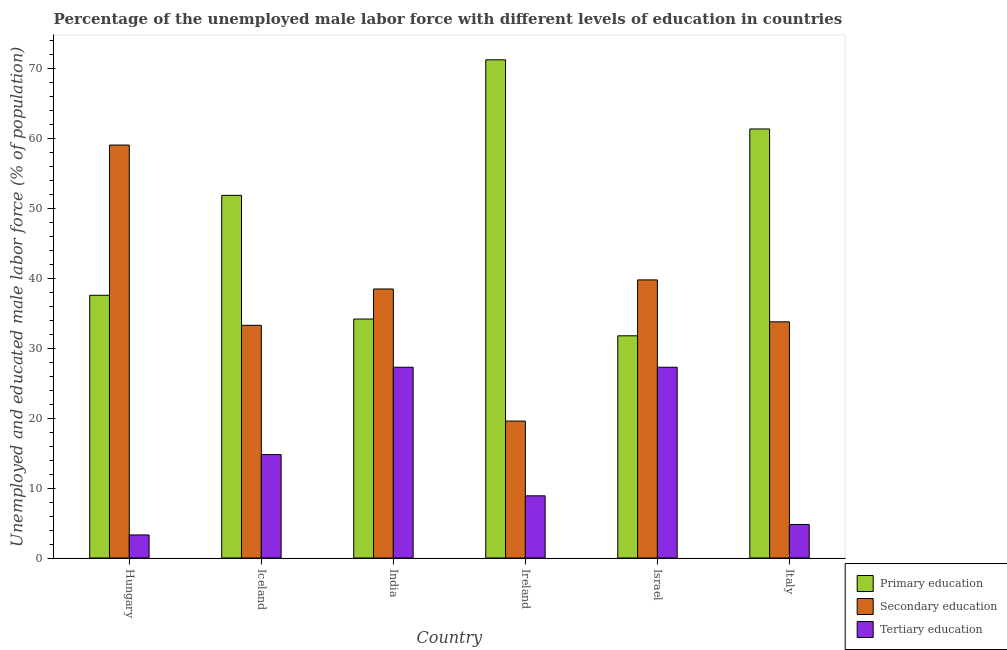How many different coloured bars are there?
Your answer should be very brief. 3. How many bars are there on the 1st tick from the left?
Keep it short and to the point. 3. How many bars are there on the 1st tick from the right?
Ensure brevity in your answer.  3. What is the label of the 4th group of bars from the left?
Ensure brevity in your answer.  Ireland. In how many cases, is the number of bars for a given country not equal to the number of legend labels?
Keep it short and to the point. 0. What is the percentage of male labor force who received primary education in Hungary?
Your answer should be very brief. 37.6. Across all countries, what is the maximum percentage of male labor force who received secondary education?
Provide a short and direct response. 59.1. Across all countries, what is the minimum percentage of male labor force who received secondary education?
Ensure brevity in your answer.  19.6. What is the total percentage of male labor force who received primary education in the graph?
Your answer should be compact. 288.2. What is the difference between the percentage of male labor force who received tertiary education in Hungary and that in Israel?
Provide a short and direct response. -24. What is the difference between the percentage of male labor force who received tertiary education in Iceland and the percentage of male labor force who received secondary education in Ireland?
Provide a short and direct response. -4.8. What is the average percentage of male labor force who received secondary education per country?
Offer a very short reply. 37.35. What is the difference between the percentage of male labor force who received tertiary education and percentage of male labor force who received secondary education in Ireland?
Make the answer very short. -10.7. In how many countries, is the percentage of male labor force who received tertiary education greater than 4 %?
Keep it short and to the point. 5. What is the ratio of the percentage of male labor force who received tertiary education in Hungary to that in Iceland?
Provide a short and direct response. 0.22. Is the difference between the percentage of male labor force who received primary education in Hungary and Iceland greater than the difference between the percentage of male labor force who received tertiary education in Hungary and Iceland?
Give a very brief answer. No. What is the difference between the highest and the second highest percentage of male labor force who received primary education?
Offer a very short reply. 9.9. What is the difference between the highest and the lowest percentage of male labor force who received secondary education?
Give a very brief answer. 39.5. In how many countries, is the percentage of male labor force who received primary education greater than the average percentage of male labor force who received primary education taken over all countries?
Offer a terse response. 3. Is the sum of the percentage of male labor force who received secondary education in Israel and Italy greater than the maximum percentage of male labor force who received primary education across all countries?
Make the answer very short. Yes. What does the 1st bar from the left in Hungary represents?
Ensure brevity in your answer.  Primary education. What does the 1st bar from the right in Italy represents?
Your answer should be very brief. Tertiary education. How many bars are there?
Offer a terse response. 18. Are all the bars in the graph horizontal?
Offer a terse response. No. How many countries are there in the graph?
Your answer should be compact. 6. What is the title of the graph?
Make the answer very short. Percentage of the unemployed male labor force with different levels of education in countries. What is the label or title of the X-axis?
Ensure brevity in your answer.  Country. What is the label or title of the Y-axis?
Offer a very short reply. Unemployed and educated male labor force (% of population). What is the Unemployed and educated male labor force (% of population) of Primary education in Hungary?
Make the answer very short. 37.6. What is the Unemployed and educated male labor force (% of population) in Secondary education in Hungary?
Your answer should be compact. 59.1. What is the Unemployed and educated male labor force (% of population) in Tertiary education in Hungary?
Offer a terse response. 3.3. What is the Unemployed and educated male labor force (% of population) of Primary education in Iceland?
Your answer should be very brief. 51.9. What is the Unemployed and educated male labor force (% of population) of Secondary education in Iceland?
Provide a short and direct response. 33.3. What is the Unemployed and educated male labor force (% of population) of Tertiary education in Iceland?
Offer a very short reply. 14.8. What is the Unemployed and educated male labor force (% of population) of Primary education in India?
Provide a succinct answer. 34.2. What is the Unemployed and educated male labor force (% of population) in Secondary education in India?
Keep it short and to the point. 38.5. What is the Unemployed and educated male labor force (% of population) of Tertiary education in India?
Keep it short and to the point. 27.3. What is the Unemployed and educated male labor force (% of population) of Primary education in Ireland?
Your answer should be compact. 71.3. What is the Unemployed and educated male labor force (% of population) of Secondary education in Ireland?
Your answer should be very brief. 19.6. What is the Unemployed and educated male labor force (% of population) in Tertiary education in Ireland?
Ensure brevity in your answer.  8.9. What is the Unemployed and educated male labor force (% of population) in Primary education in Israel?
Provide a short and direct response. 31.8. What is the Unemployed and educated male labor force (% of population) of Secondary education in Israel?
Your answer should be compact. 39.8. What is the Unemployed and educated male labor force (% of population) in Tertiary education in Israel?
Offer a terse response. 27.3. What is the Unemployed and educated male labor force (% of population) in Primary education in Italy?
Offer a very short reply. 61.4. What is the Unemployed and educated male labor force (% of population) in Secondary education in Italy?
Provide a short and direct response. 33.8. What is the Unemployed and educated male labor force (% of population) of Tertiary education in Italy?
Keep it short and to the point. 4.8. Across all countries, what is the maximum Unemployed and educated male labor force (% of population) in Primary education?
Make the answer very short. 71.3. Across all countries, what is the maximum Unemployed and educated male labor force (% of population) of Secondary education?
Provide a succinct answer. 59.1. Across all countries, what is the maximum Unemployed and educated male labor force (% of population) of Tertiary education?
Your response must be concise. 27.3. Across all countries, what is the minimum Unemployed and educated male labor force (% of population) of Primary education?
Give a very brief answer. 31.8. Across all countries, what is the minimum Unemployed and educated male labor force (% of population) of Secondary education?
Your response must be concise. 19.6. Across all countries, what is the minimum Unemployed and educated male labor force (% of population) of Tertiary education?
Make the answer very short. 3.3. What is the total Unemployed and educated male labor force (% of population) in Primary education in the graph?
Provide a short and direct response. 288.2. What is the total Unemployed and educated male labor force (% of population) of Secondary education in the graph?
Offer a very short reply. 224.1. What is the total Unemployed and educated male labor force (% of population) in Tertiary education in the graph?
Give a very brief answer. 86.4. What is the difference between the Unemployed and educated male labor force (% of population) in Primary education in Hungary and that in Iceland?
Give a very brief answer. -14.3. What is the difference between the Unemployed and educated male labor force (% of population) of Secondary education in Hungary and that in Iceland?
Offer a terse response. 25.8. What is the difference between the Unemployed and educated male labor force (% of population) in Tertiary education in Hungary and that in Iceland?
Provide a short and direct response. -11.5. What is the difference between the Unemployed and educated male labor force (% of population) in Secondary education in Hungary and that in India?
Keep it short and to the point. 20.6. What is the difference between the Unemployed and educated male labor force (% of population) of Primary education in Hungary and that in Ireland?
Your answer should be compact. -33.7. What is the difference between the Unemployed and educated male labor force (% of population) in Secondary education in Hungary and that in Ireland?
Offer a very short reply. 39.5. What is the difference between the Unemployed and educated male labor force (% of population) in Secondary education in Hungary and that in Israel?
Offer a terse response. 19.3. What is the difference between the Unemployed and educated male labor force (% of population) in Tertiary education in Hungary and that in Israel?
Offer a very short reply. -24. What is the difference between the Unemployed and educated male labor force (% of population) of Primary education in Hungary and that in Italy?
Offer a terse response. -23.8. What is the difference between the Unemployed and educated male labor force (% of population) in Secondary education in Hungary and that in Italy?
Your answer should be very brief. 25.3. What is the difference between the Unemployed and educated male labor force (% of population) in Tertiary education in Hungary and that in Italy?
Your answer should be very brief. -1.5. What is the difference between the Unemployed and educated male labor force (% of population) in Primary education in Iceland and that in India?
Provide a succinct answer. 17.7. What is the difference between the Unemployed and educated male labor force (% of population) of Tertiary education in Iceland and that in India?
Keep it short and to the point. -12.5. What is the difference between the Unemployed and educated male labor force (% of population) of Primary education in Iceland and that in Ireland?
Your answer should be very brief. -19.4. What is the difference between the Unemployed and educated male labor force (% of population) of Tertiary education in Iceland and that in Ireland?
Give a very brief answer. 5.9. What is the difference between the Unemployed and educated male labor force (% of population) of Primary education in Iceland and that in Israel?
Your answer should be very brief. 20.1. What is the difference between the Unemployed and educated male labor force (% of population) of Secondary education in Iceland and that in Israel?
Your answer should be very brief. -6.5. What is the difference between the Unemployed and educated male labor force (% of population) of Tertiary education in Iceland and that in Israel?
Provide a succinct answer. -12.5. What is the difference between the Unemployed and educated male labor force (% of population) of Secondary education in Iceland and that in Italy?
Your answer should be compact. -0.5. What is the difference between the Unemployed and educated male labor force (% of population) of Tertiary education in Iceland and that in Italy?
Keep it short and to the point. 10. What is the difference between the Unemployed and educated male labor force (% of population) of Primary education in India and that in Ireland?
Keep it short and to the point. -37.1. What is the difference between the Unemployed and educated male labor force (% of population) in Secondary education in India and that in Ireland?
Offer a very short reply. 18.9. What is the difference between the Unemployed and educated male labor force (% of population) of Primary education in India and that in Italy?
Your response must be concise. -27.2. What is the difference between the Unemployed and educated male labor force (% of population) in Tertiary education in India and that in Italy?
Your response must be concise. 22.5. What is the difference between the Unemployed and educated male labor force (% of population) of Primary education in Ireland and that in Israel?
Offer a very short reply. 39.5. What is the difference between the Unemployed and educated male labor force (% of population) in Secondary education in Ireland and that in Israel?
Offer a very short reply. -20.2. What is the difference between the Unemployed and educated male labor force (% of population) of Tertiary education in Ireland and that in Israel?
Keep it short and to the point. -18.4. What is the difference between the Unemployed and educated male labor force (% of population) of Primary education in Ireland and that in Italy?
Make the answer very short. 9.9. What is the difference between the Unemployed and educated male labor force (% of population) in Tertiary education in Ireland and that in Italy?
Your answer should be very brief. 4.1. What is the difference between the Unemployed and educated male labor force (% of population) in Primary education in Israel and that in Italy?
Your answer should be very brief. -29.6. What is the difference between the Unemployed and educated male labor force (% of population) of Tertiary education in Israel and that in Italy?
Your answer should be very brief. 22.5. What is the difference between the Unemployed and educated male labor force (% of population) in Primary education in Hungary and the Unemployed and educated male labor force (% of population) in Tertiary education in Iceland?
Give a very brief answer. 22.8. What is the difference between the Unemployed and educated male labor force (% of population) of Secondary education in Hungary and the Unemployed and educated male labor force (% of population) of Tertiary education in Iceland?
Your answer should be very brief. 44.3. What is the difference between the Unemployed and educated male labor force (% of population) in Primary education in Hungary and the Unemployed and educated male labor force (% of population) in Secondary education in India?
Offer a very short reply. -0.9. What is the difference between the Unemployed and educated male labor force (% of population) of Primary education in Hungary and the Unemployed and educated male labor force (% of population) of Tertiary education in India?
Provide a succinct answer. 10.3. What is the difference between the Unemployed and educated male labor force (% of population) in Secondary education in Hungary and the Unemployed and educated male labor force (% of population) in Tertiary education in India?
Your answer should be very brief. 31.8. What is the difference between the Unemployed and educated male labor force (% of population) in Primary education in Hungary and the Unemployed and educated male labor force (% of population) in Tertiary education in Ireland?
Provide a short and direct response. 28.7. What is the difference between the Unemployed and educated male labor force (% of population) in Secondary education in Hungary and the Unemployed and educated male labor force (% of population) in Tertiary education in Ireland?
Offer a terse response. 50.2. What is the difference between the Unemployed and educated male labor force (% of population) of Primary education in Hungary and the Unemployed and educated male labor force (% of population) of Secondary education in Israel?
Keep it short and to the point. -2.2. What is the difference between the Unemployed and educated male labor force (% of population) in Primary education in Hungary and the Unemployed and educated male labor force (% of population) in Tertiary education in Israel?
Make the answer very short. 10.3. What is the difference between the Unemployed and educated male labor force (% of population) in Secondary education in Hungary and the Unemployed and educated male labor force (% of population) in Tertiary education in Israel?
Offer a terse response. 31.8. What is the difference between the Unemployed and educated male labor force (% of population) of Primary education in Hungary and the Unemployed and educated male labor force (% of population) of Tertiary education in Italy?
Make the answer very short. 32.8. What is the difference between the Unemployed and educated male labor force (% of population) in Secondary education in Hungary and the Unemployed and educated male labor force (% of population) in Tertiary education in Italy?
Provide a succinct answer. 54.3. What is the difference between the Unemployed and educated male labor force (% of population) of Primary education in Iceland and the Unemployed and educated male labor force (% of population) of Secondary education in India?
Your response must be concise. 13.4. What is the difference between the Unemployed and educated male labor force (% of population) in Primary education in Iceland and the Unemployed and educated male labor force (% of population) in Tertiary education in India?
Your answer should be compact. 24.6. What is the difference between the Unemployed and educated male labor force (% of population) in Primary education in Iceland and the Unemployed and educated male labor force (% of population) in Secondary education in Ireland?
Offer a terse response. 32.3. What is the difference between the Unemployed and educated male labor force (% of population) of Secondary education in Iceland and the Unemployed and educated male labor force (% of population) of Tertiary education in Ireland?
Provide a succinct answer. 24.4. What is the difference between the Unemployed and educated male labor force (% of population) in Primary education in Iceland and the Unemployed and educated male labor force (% of population) in Secondary education in Israel?
Your response must be concise. 12.1. What is the difference between the Unemployed and educated male labor force (% of population) of Primary education in Iceland and the Unemployed and educated male labor force (% of population) of Tertiary education in Israel?
Give a very brief answer. 24.6. What is the difference between the Unemployed and educated male labor force (% of population) of Primary education in Iceland and the Unemployed and educated male labor force (% of population) of Tertiary education in Italy?
Make the answer very short. 47.1. What is the difference between the Unemployed and educated male labor force (% of population) in Primary education in India and the Unemployed and educated male labor force (% of population) in Secondary education in Ireland?
Give a very brief answer. 14.6. What is the difference between the Unemployed and educated male labor force (% of population) in Primary education in India and the Unemployed and educated male labor force (% of population) in Tertiary education in Ireland?
Your answer should be very brief. 25.3. What is the difference between the Unemployed and educated male labor force (% of population) of Secondary education in India and the Unemployed and educated male labor force (% of population) of Tertiary education in Ireland?
Provide a succinct answer. 29.6. What is the difference between the Unemployed and educated male labor force (% of population) in Primary education in India and the Unemployed and educated male labor force (% of population) in Secondary education in Israel?
Provide a short and direct response. -5.6. What is the difference between the Unemployed and educated male labor force (% of population) of Primary education in India and the Unemployed and educated male labor force (% of population) of Tertiary education in Israel?
Provide a short and direct response. 6.9. What is the difference between the Unemployed and educated male labor force (% of population) in Secondary education in India and the Unemployed and educated male labor force (% of population) in Tertiary education in Israel?
Your response must be concise. 11.2. What is the difference between the Unemployed and educated male labor force (% of population) of Primary education in India and the Unemployed and educated male labor force (% of population) of Secondary education in Italy?
Make the answer very short. 0.4. What is the difference between the Unemployed and educated male labor force (% of population) of Primary education in India and the Unemployed and educated male labor force (% of population) of Tertiary education in Italy?
Provide a succinct answer. 29.4. What is the difference between the Unemployed and educated male labor force (% of population) in Secondary education in India and the Unemployed and educated male labor force (% of population) in Tertiary education in Italy?
Provide a succinct answer. 33.7. What is the difference between the Unemployed and educated male labor force (% of population) in Primary education in Ireland and the Unemployed and educated male labor force (% of population) in Secondary education in Israel?
Offer a very short reply. 31.5. What is the difference between the Unemployed and educated male labor force (% of population) of Primary education in Ireland and the Unemployed and educated male labor force (% of population) of Tertiary education in Israel?
Make the answer very short. 44. What is the difference between the Unemployed and educated male labor force (% of population) of Primary education in Ireland and the Unemployed and educated male labor force (% of population) of Secondary education in Italy?
Keep it short and to the point. 37.5. What is the difference between the Unemployed and educated male labor force (% of population) in Primary education in Ireland and the Unemployed and educated male labor force (% of population) in Tertiary education in Italy?
Offer a terse response. 66.5. What is the difference between the Unemployed and educated male labor force (% of population) of Secondary education in Ireland and the Unemployed and educated male labor force (% of population) of Tertiary education in Italy?
Your answer should be very brief. 14.8. What is the difference between the Unemployed and educated male labor force (% of population) of Primary education in Israel and the Unemployed and educated male labor force (% of population) of Tertiary education in Italy?
Offer a terse response. 27. What is the average Unemployed and educated male labor force (% of population) of Primary education per country?
Keep it short and to the point. 48.03. What is the average Unemployed and educated male labor force (% of population) in Secondary education per country?
Your answer should be very brief. 37.35. What is the difference between the Unemployed and educated male labor force (% of population) of Primary education and Unemployed and educated male labor force (% of population) of Secondary education in Hungary?
Provide a short and direct response. -21.5. What is the difference between the Unemployed and educated male labor force (% of population) of Primary education and Unemployed and educated male labor force (% of population) of Tertiary education in Hungary?
Your answer should be very brief. 34.3. What is the difference between the Unemployed and educated male labor force (% of population) in Secondary education and Unemployed and educated male labor force (% of population) in Tertiary education in Hungary?
Your answer should be compact. 55.8. What is the difference between the Unemployed and educated male labor force (% of population) of Primary education and Unemployed and educated male labor force (% of population) of Tertiary education in Iceland?
Offer a very short reply. 37.1. What is the difference between the Unemployed and educated male labor force (% of population) of Secondary education and Unemployed and educated male labor force (% of population) of Tertiary education in Iceland?
Your response must be concise. 18.5. What is the difference between the Unemployed and educated male labor force (% of population) in Primary education and Unemployed and educated male labor force (% of population) in Tertiary education in India?
Offer a terse response. 6.9. What is the difference between the Unemployed and educated male labor force (% of population) of Secondary education and Unemployed and educated male labor force (% of population) of Tertiary education in India?
Your answer should be very brief. 11.2. What is the difference between the Unemployed and educated male labor force (% of population) of Primary education and Unemployed and educated male labor force (% of population) of Secondary education in Ireland?
Provide a short and direct response. 51.7. What is the difference between the Unemployed and educated male labor force (% of population) in Primary education and Unemployed and educated male labor force (% of population) in Tertiary education in Ireland?
Provide a short and direct response. 62.4. What is the difference between the Unemployed and educated male labor force (% of population) in Secondary education and Unemployed and educated male labor force (% of population) in Tertiary education in Ireland?
Your answer should be very brief. 10.7. What is the difference between the Unemployed and educated male labor force (% of population) in Primary education and Unemployed and educated male labor force (% of population) in Secondary education in Italy?
Provide a short and direct response. 27.6. What is the difference between the Unemployed and educated male labor force (% of population) of Primary education and Unemployed and educated male labor force (% of population) of Tertiary education in Italy?
Your answer should be compact. 56.6. What is the ratio of the Unemployed and educated male labor force (% of population) of Primary education in Hungary to that in Iceland?
Keep it short and to the point. 0.72. What is the ratio of the Unemployed and educated male labor force (% of population) in Secondary education in Hungary to that in Iceland?
Provide a succinct answer. 1.77. What is the ratio of the Unemployed and educated male labor force (% of population) of Tertiary education in Hungary to that in Iceland?
Offer a terse response. 0.22. What is the ratio of the Unemployed and educated male labor force (% of population) of Primary education in Hungary to that in India?
Your answer should be very brief. 1.1. What is the ratio of the Unemployed and educated male labor force (% of population) of Secondary education in Hungary to that in India?
Your answer should be compact. 1.54. What is the ratio of the Unemployed and educated male labor force (% of population) of Tertiary education in Hungary to that in India?
Offer a very short reply. 0.12. What is the ratio of the Unemployed and educated male labor force (% of population) in Primary education in Hungary to that in Ireland?
Offer a terse response. 0.53. What is the ratio of the Unemployed and educated male labor force (% of population) of Secondary education in Hungary to that in Ireland?
Give a very brief answer. 3.02. What is the ratio of the Unemployed and educated male labor force (% of population) in Tertiary education in Hungary to that in Ireland?
Offer a very short reply. 0.37. What is the ratio of the Unemployed and educated male labor force (% of population) in Primary education in Hungary to that in Israel?
Offer a very short reply. 1.18. What is the ratio of the Unemployed and educated male labor force (% of population) of Secondary education in Hungary to that in Israel?
Keep it short and to the point. 1.48. What is the ratio of the Unemployed and educated male labor force (% of population) in Tertiary education in Hungary to that in Israel?
Offer a terse response. 0.12. What is the ratio of the Unemployed and educated male labor force (% of population) in Primary education in Hungary to that in Italy?
Give a very brief answer. 0.61. What is the ratio of the Unemployed and educated male labor force (% of population) in Secondary education in Hungary to that in Italy?
Keep it short and to the point. 1.75. What is the ratio of the Unemployed and educated male labor force (% of population) of Tertiary education in Hungary to that in Italy?
Your answer should be very brief. 0.69. What is the ratio of the Unemployed and educated male labor force (% of population) of Primary education in Iceland to that in India?
Ensure brevity in your answer.  1.52. What is the ratio of the Unemployed and educated male labor force (% of population) of Secondary education in Iceland to that in India?
Keep it short and to the point. 0.86. What is the ratio of the Unemployed and educated male labor force (% of population) of Tertiary education in Iceland to that in India?
Make the answer very short. 0.54. What is the ratio of the Unemployed and educated male labor force (% of population) in Primary education in Iceland to that in Ireland?
Provide a short and direct response. 0.73. What is the ratio of the Unemployed and educated male labor force (% of population) in Secondary education in Iceland to that in Ireland?
Provide a succinct answer. 1.7. What is the ratio of the Unemployed and educated male labor force (% of population) in Tertiary education in Iceland to that in Ireland?
Offer a very short reply. 1.66. What is the ratio of the Unemployed and educated male labor force (% of population) of Primary education in Iceland to that in Israel?
Offer a terse response. 1.63. What is the ratio of the Unemployed and educated male labor force (% of population) in Secondary education in Iceland to that in Israel?
Your response must be concise. 0.84. What is the ratio of the Unemployed and educated male labor force (% of population) of Tertiary education in Iceland to that in Israel?
Provide a short and direct response. 0.54. What is the ratio of the Unemployed and educated male labor force (% of population) in Primary education in Iceland to that in Italy?
Provide a short and direct response. 0.85. What is the ratio of the Unemployed and educated male labor force (% of population) in Secondary education in Iceland to that in Italy?
Your response must be concise. 0.99. What is the ratio of the Unemployed and educated male labor force (% of population) of Tertiary education in Iceland to that in Italy?
Provide a short and direct response. 3.08. What is the ratio of the Unemployed and educated male labor force (% of population) of Primary education in India to that in Ireland?
Provide a succinct answer. 0.48. What is the ratio of the Unemployed and educated male labor force (% of population) of Secondary education in India to that in Ireland?
Provide a short and direct response. 1.96. What is the ratio of the Unemployed and educated male labor force (% of population) of Tertiary education in India to that in Ireland?
Your answer should be compact. 3.07. What is the ratio of the Unemployed and educated male labor force (% of population) in Primary education in India to that in Israel?
Provide a short and direct response. 1.08. What is the ratio of the Unemployed and educated male labor force (% of population) of Secondary education in India to that in Israel?
Provide a short and direct response. 0.97. What is the ratio of the Unemployed and educated male labor force (% of population) of Tertiary education in India to that in Israel?
Ensure brevity in your answer.  1. What is the ratio of the Unemployed and educated male labor force (% of population) in Primary education in India to that in Italy?
Your response must be concise. 0.56. What is the ratio of the Unemployed and educated male labor force (% of population) of Secondary education in India to that in Italy?
Give a very brief answer. 1.14. What is the ratio of the Unemployed and educated male labor force (% of population) in Tertiary education in India to that in Italy?
Your answer should be compact. 5.69. What is the ratio of the Unemployed and educated male labor force (% of population) in Primary education in Ireland to that in Israel?
Your answer should be very brief. 2.24. What is the ratio of the Unemployed and educated male labor force (% of population) of Secondary education in Ireland to that in Israel?
Provide a short and direct response. 0.49. What is the ratio of the Unemployed and educated male labor force (% of population) of Tertiary education in Ireland to that in Israel?
Give a very brief answer. 0.33. What is the ratio of the Unemployed and educated male labor force (% of population) in Primary education in Ireland to that in Italy?
Make the answer very short. 1.16. What is the ratio of the Unemployed and educated male labor force (% of population) of Secondary education in Ireland to that in Italy?
Keep it short and to the point. 0.58. What is the ratio of the Unemployed and educated male labor force (% of population) of Tertiary education in Ireland to that in Italy?
Offer a very short reply. 1.85. What is the ratio of the Unemployed and educated male labor force (% of population) in Primary education in Israel to that in Italy?
Make the answer very short. 0.52. What is the ratio of the Unemployed and educated male labor force (% of population) of Secondary education in Israel to that in Italy?
Your response must be concise. 1.18. What is the ratio of the Unemployed and educated male labor force (% of population) in Tertiary education in Israel to that in Italy?
Make the answer very short. 5.69. What is the difference between the highest and the second highest Unemployed and educated male labor force (% of population) in Secondary education?
Offer a very short reply. 19.3. What is the difference between the highest and the lowest Unemployed and educated male labor force (% of population) in Primary education?
Ensure brevity in your answer.  39.5. What is the difference between the highest and the lowest Unemployed and educated male labor force (% of population) of Secondary education?
Keep it short and to the point. 39.5. What is the difference between the highest and the lowest Unemployed and educated male labor force (% of population) in Tertiary education?
Offer a very short reply. 24. 